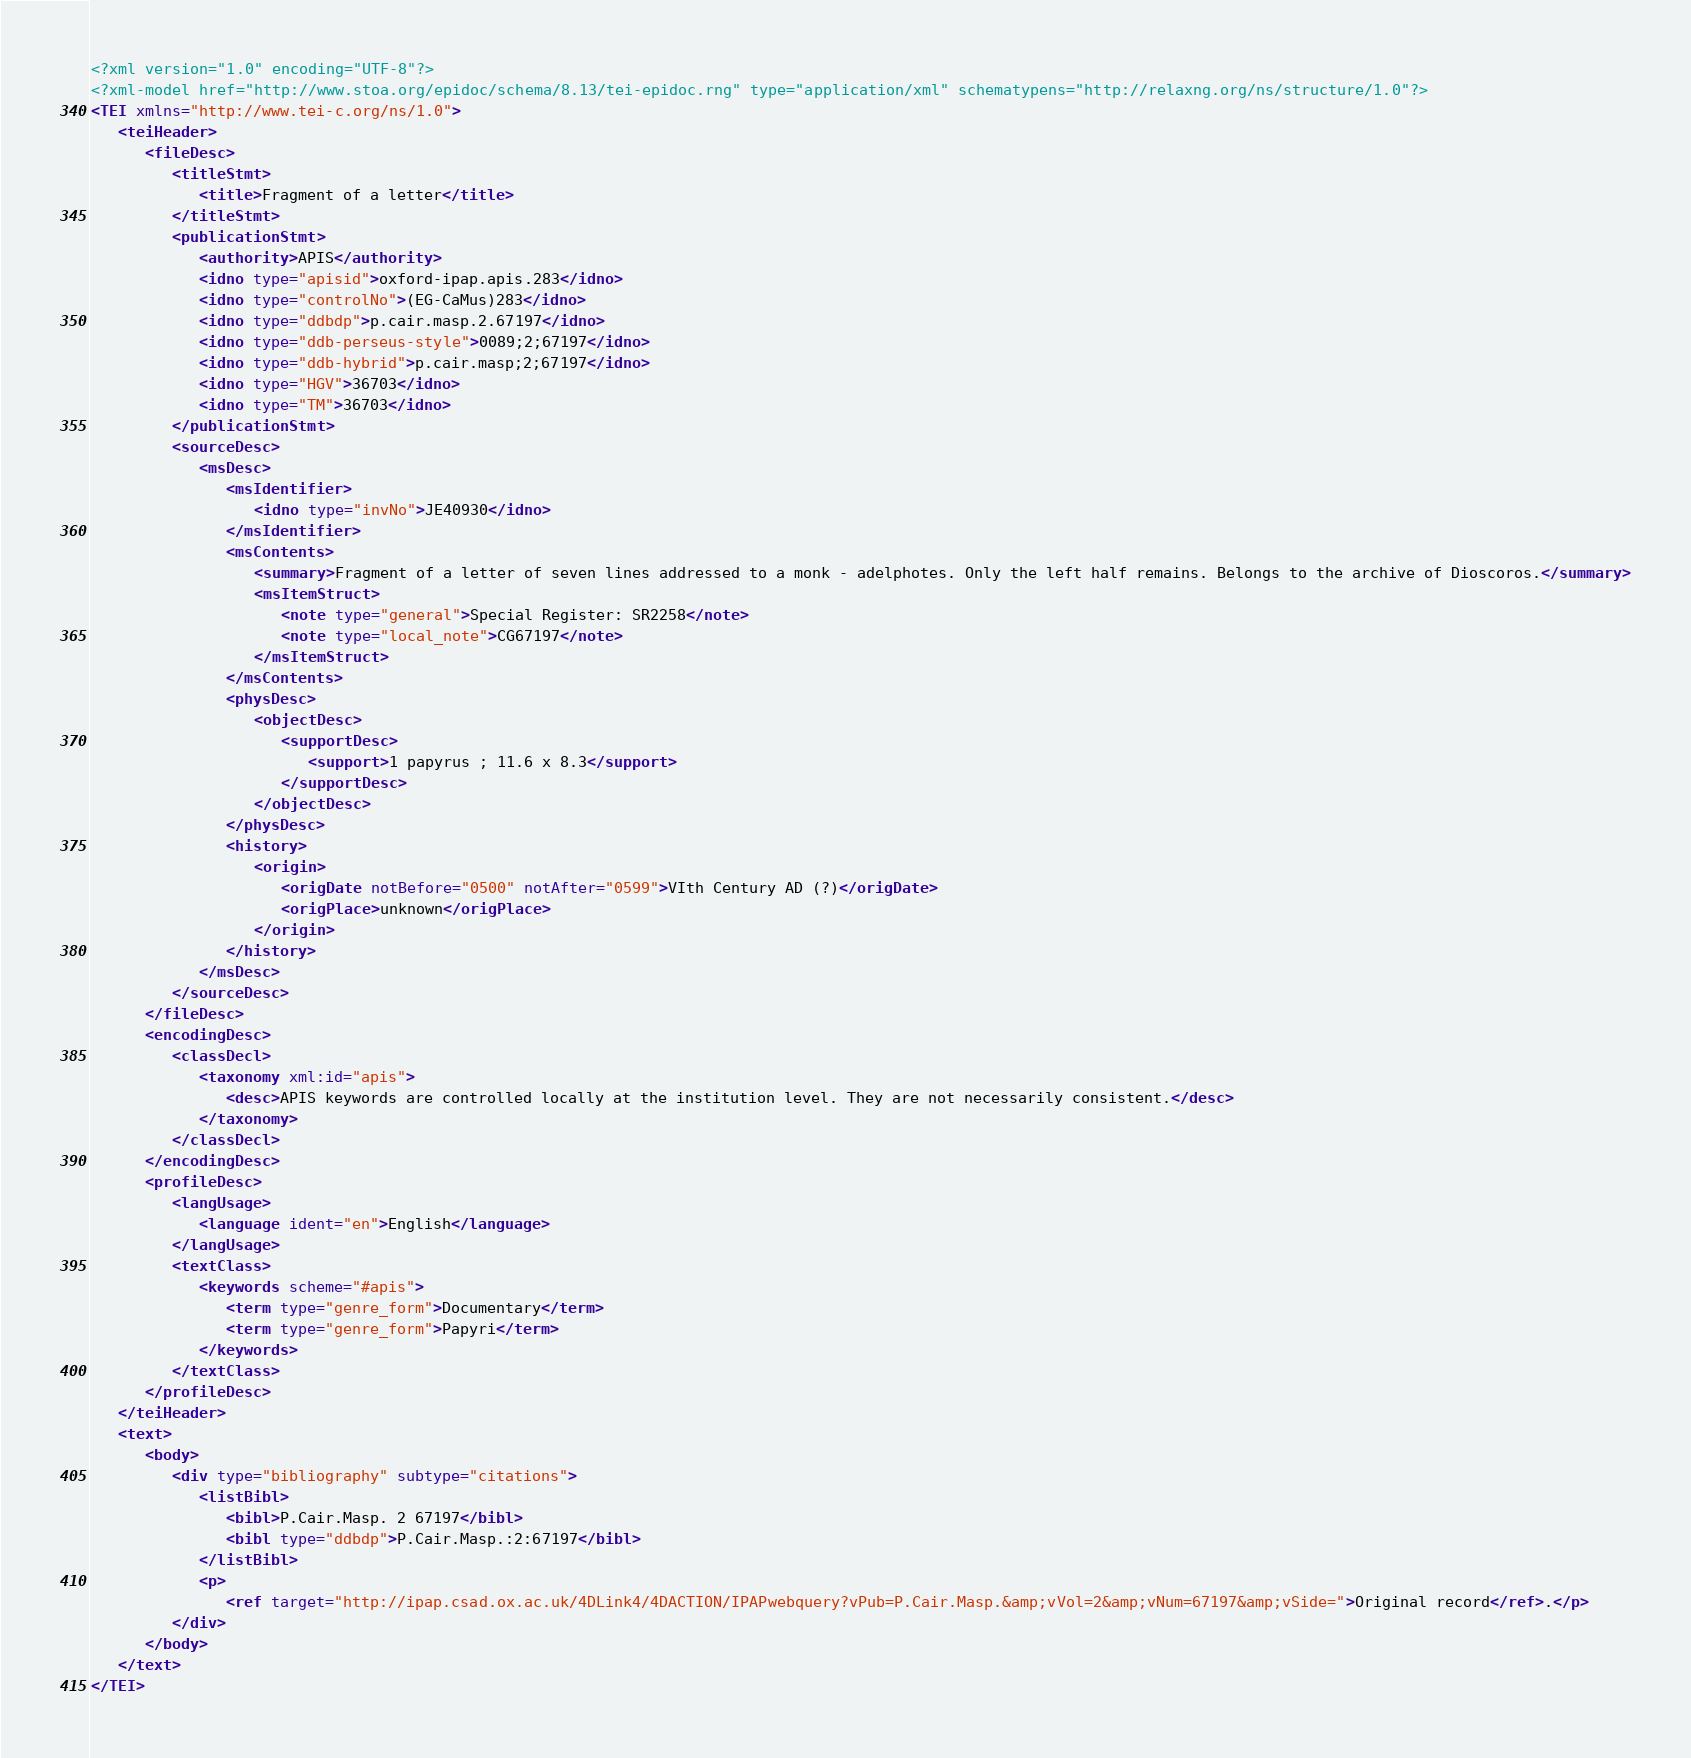Convert code to text. <code><loc_0><loc_0><loc_500><loc_500><_XML_><?xml version="1.0" encoding="UTF-8"?>
<?xml-model href="http://www.stoa.org/epidoc/schema/8.13/tei-epidoc.rng" type="application/xml" schematypens="http://relaxng.org/ns/structure/1.0"?>
<TEI xmlns="http://www.tei-c.org/ns/1.0">
   <teiHeader>
      <fileDesc>
         <titleStmt>
            <title>Fragment of a letter</title>
         </titleStmt>
         <publicationStmt>
            <authority>APIS</authority>
            <idno type="apisid">oxford-ipap.apis.283</idno>
            <idno type="controlNo">(EG-CaMus)283</idno>
            <idno type="ddbdp">p.cair.masp.2.67197</idno>
            <idno type="ddb-perseus-style">0089;2;67197</idno>
            <idno type="ddb-hybrid">p.cair.masp;2;67197</idno>
            <idno type="HGV">36703</idno>
            <idno type="TM">36703</idno>
         </publicationStmt>
         <sourceDesc>
            <msDesc>
               <msIdentifier>
                  <idno type="invNo">JE40930</idno>
               </msIdentifier>
               <msContents>
                  <summary>Fragment of a letter of seven lines addressed to a monk - adelphotes. Only the left half remains. Belongs to the archive of Dioscoros.</summary>
                  <msItemStruct>
                     <note type="general">Special Register: SR2258</note>
                     <note type="local_note">CG67197</note>
                  </msItemStruct>
               </msContents>
               <physDesc>
                  <objectDesc>
                     <supportDesc>
                        <support>1 papyrus ; 11.6 x 8.3</support>
                     </supportDesc>
                  </objectDesc>
               </physDesc>
               <history>
                  <origin>
                     <origDate notBefore="0500" notAfter="0599">VIth Century AD (?)</origDate>
                     <origPlace>unknown</origPlace>
                  </origin>
               </history>
            </msDesc>
         </sourceDesc>
      </fileDesc>
      <encodingDesc>
         <classDecl>
            <taxonomy xml:id="apis">
               <desc>APIS keywords are controlled locally at the institution level. They are not necessarily consistent.</desc>
            </taxonomy>
         </classDecl>
      </encodingDesc>
      <profileDesc>
         <langUsage>
            <language ident="en">English</language>
         </langUsage>
         <textClass>
            <keywords scheme="#apis">
               <term type="genre_form">Documentary</term>
               <term type="genre_form">Papyri</term>
            </keywords>
         </textClass>
      </profileDesc>
   </teiHeader>
   <text>
      <body>
         <div type="bibliography" subtype="citations">
            <listBibl>
               <bibl>P.Cair.Masp. 2 67197</bibl>
               <bibl type="ddbdp">P.Cair.Masp.:2:67197</bibl>
            </listBibl>
            <p>
               <ref target="http://ipap.csad.ox.ac.uk/4DLink4/4DACTION/IPAPwebquery?vPub=P.Cair.Masp.&amp;vVol=2&amp;vNum=67197&amp;vSide=">Original record</ref>.</p>
         </div>
      </body>
   </text>
</TEI>
</code> 